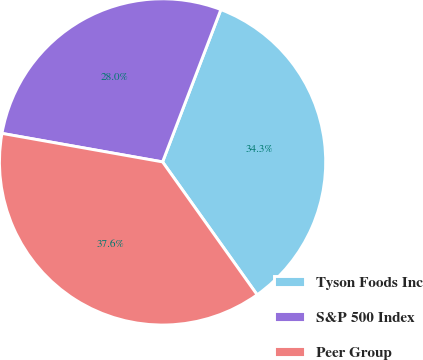<chart> <loc_0><loc_0><loc_500><loc_500><pie_chart><fcel>Tyson Foods Inc<fcel>S&P 500 Index<fcel>Peer Group<nl><fcel>34.34%<fcel>28.02%<fcel>37.64%<nl></chart> 